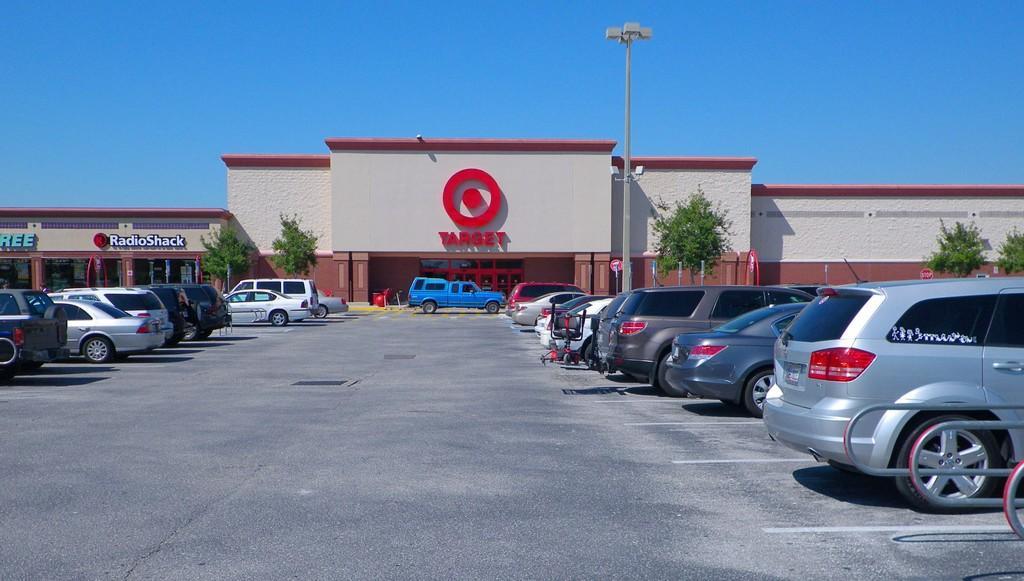In one or two sentences, can you explain what this image depicts? In this picture there are cars on the right and left side of the image and there are buildings and a pole in the center of the image and there are trees in the image. 